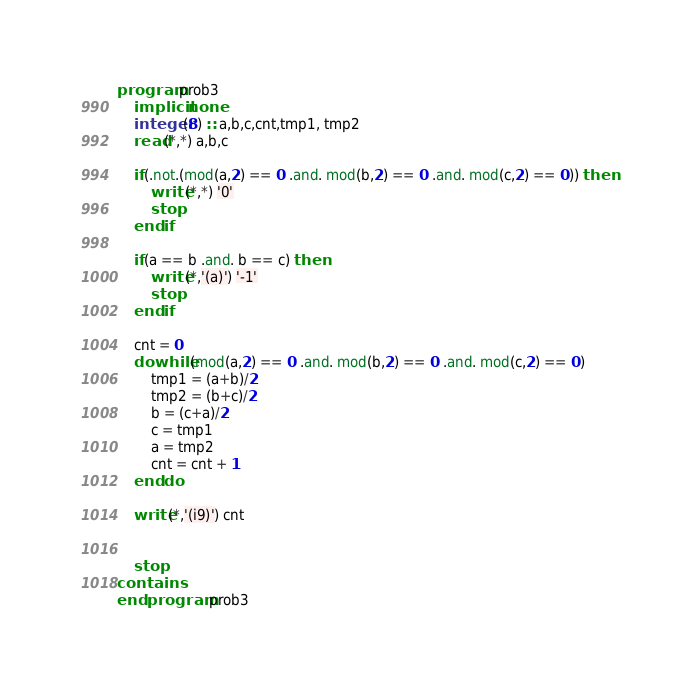Convert code to text. <code><loc_0><loc_0><loc_500><loc_500><_FORTRAN_>program prob3
    implicit none
    integer(8) :: a,b,c,cnt,tmp1, tmp2
    read(*,*) a,b,c

    if(.not.(mod(a,2) == 0 .and. mod(b,2) == 0 .and. mod(c,2) == 0)) then
        write(*,*) '0'
        stop
    end if

    if(a == b .and. b == c) then
        write(*,'(a)') '-1'
        stop
    end if

    cnt = 0
    do while(mod(a,2) == 0 .and. mod(b,2) == 0 .and. mod(c,2) == 0)
        tmp1 = (a+b)/2
        tmp2 = (b+c)/2
        b = (c+a)/2
        c = tmp1
        a = tmp2
        cnt = cnt + 1
    end do

    write(*,'(i9)') cnt 


    stop
contains
end program prob3</code> 